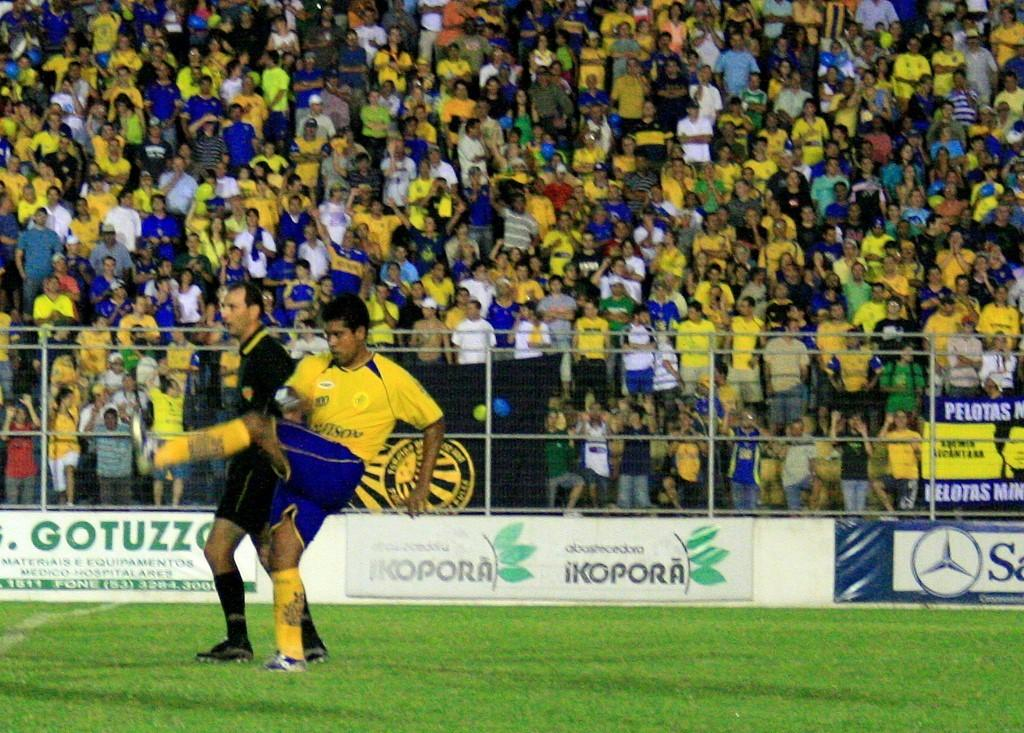<image>
Share a concise interpretation of the image provided. A soccer game is taking place with a lot of excited fans behind an IKOPORA sign. 